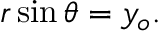Convert formula to latex. <formula><loc_0><loc_0><loc_500><loc_500>r \sin \theta = y _ { o } .</formula> 